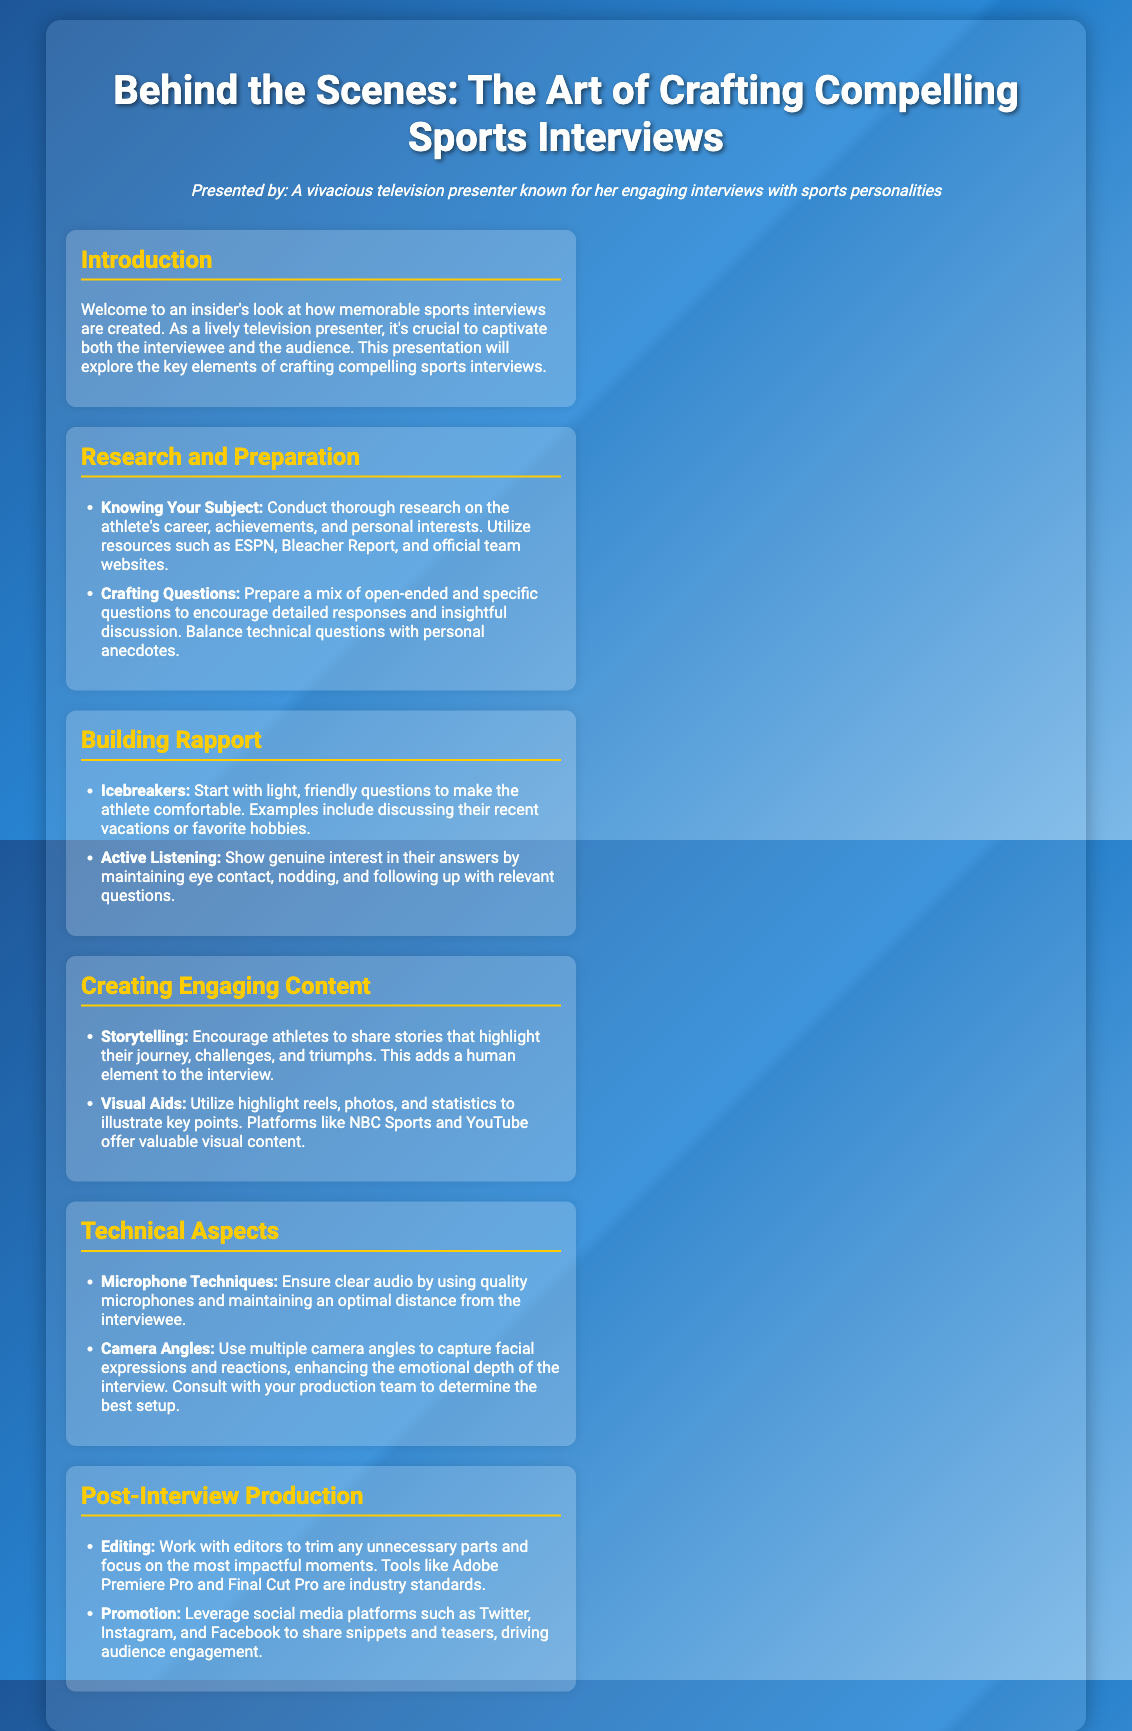What is the title of the presentation? The title is what the presentation is about and is explicitly stated at the top of the document.
Answer: Behind the Scenes: The Art of Crafting Compelling Sports Interviews Who is the presenter? The presenter is mentioned in the persona section of the document.
Answer: A vivacious television presenter known for her engaging interviews with sports personalities What is one resource mentioned for research? The document lists specific resources that can be used for research on athletes.
Answer: ESPN What is a key element in building rapport? This question focuses on a strategy outlined in the document for making the athlete comfortable during the interview.
Answer: Icebreakers What editing tools are mentioned in the post-interview production section? The document specifies tools used for editing the interviews, which is vital for the production process.
Answer: Adobe Premiere Pro and Final Cut Pro What type of questions should be prepared for the interviews? This question seeks to clarify the nature of the questions that should be crafted for interviews as stated in the document.
Answer: Open-ended and specific questions How should one ensure clear audio during an interview? This question addresses a technical aspect mentioned in the presentation.
Answer: Quality microphones What is a suggested way to promote the interview content? This question inquires about strategies mentioned in the document for engaging the audience after the interview is produced.
Answer: Social media platforms What element adds a human aspect to the interview? The document discusses storytelling as a technique to personalize the interview experience.
Answer: Storytelling 